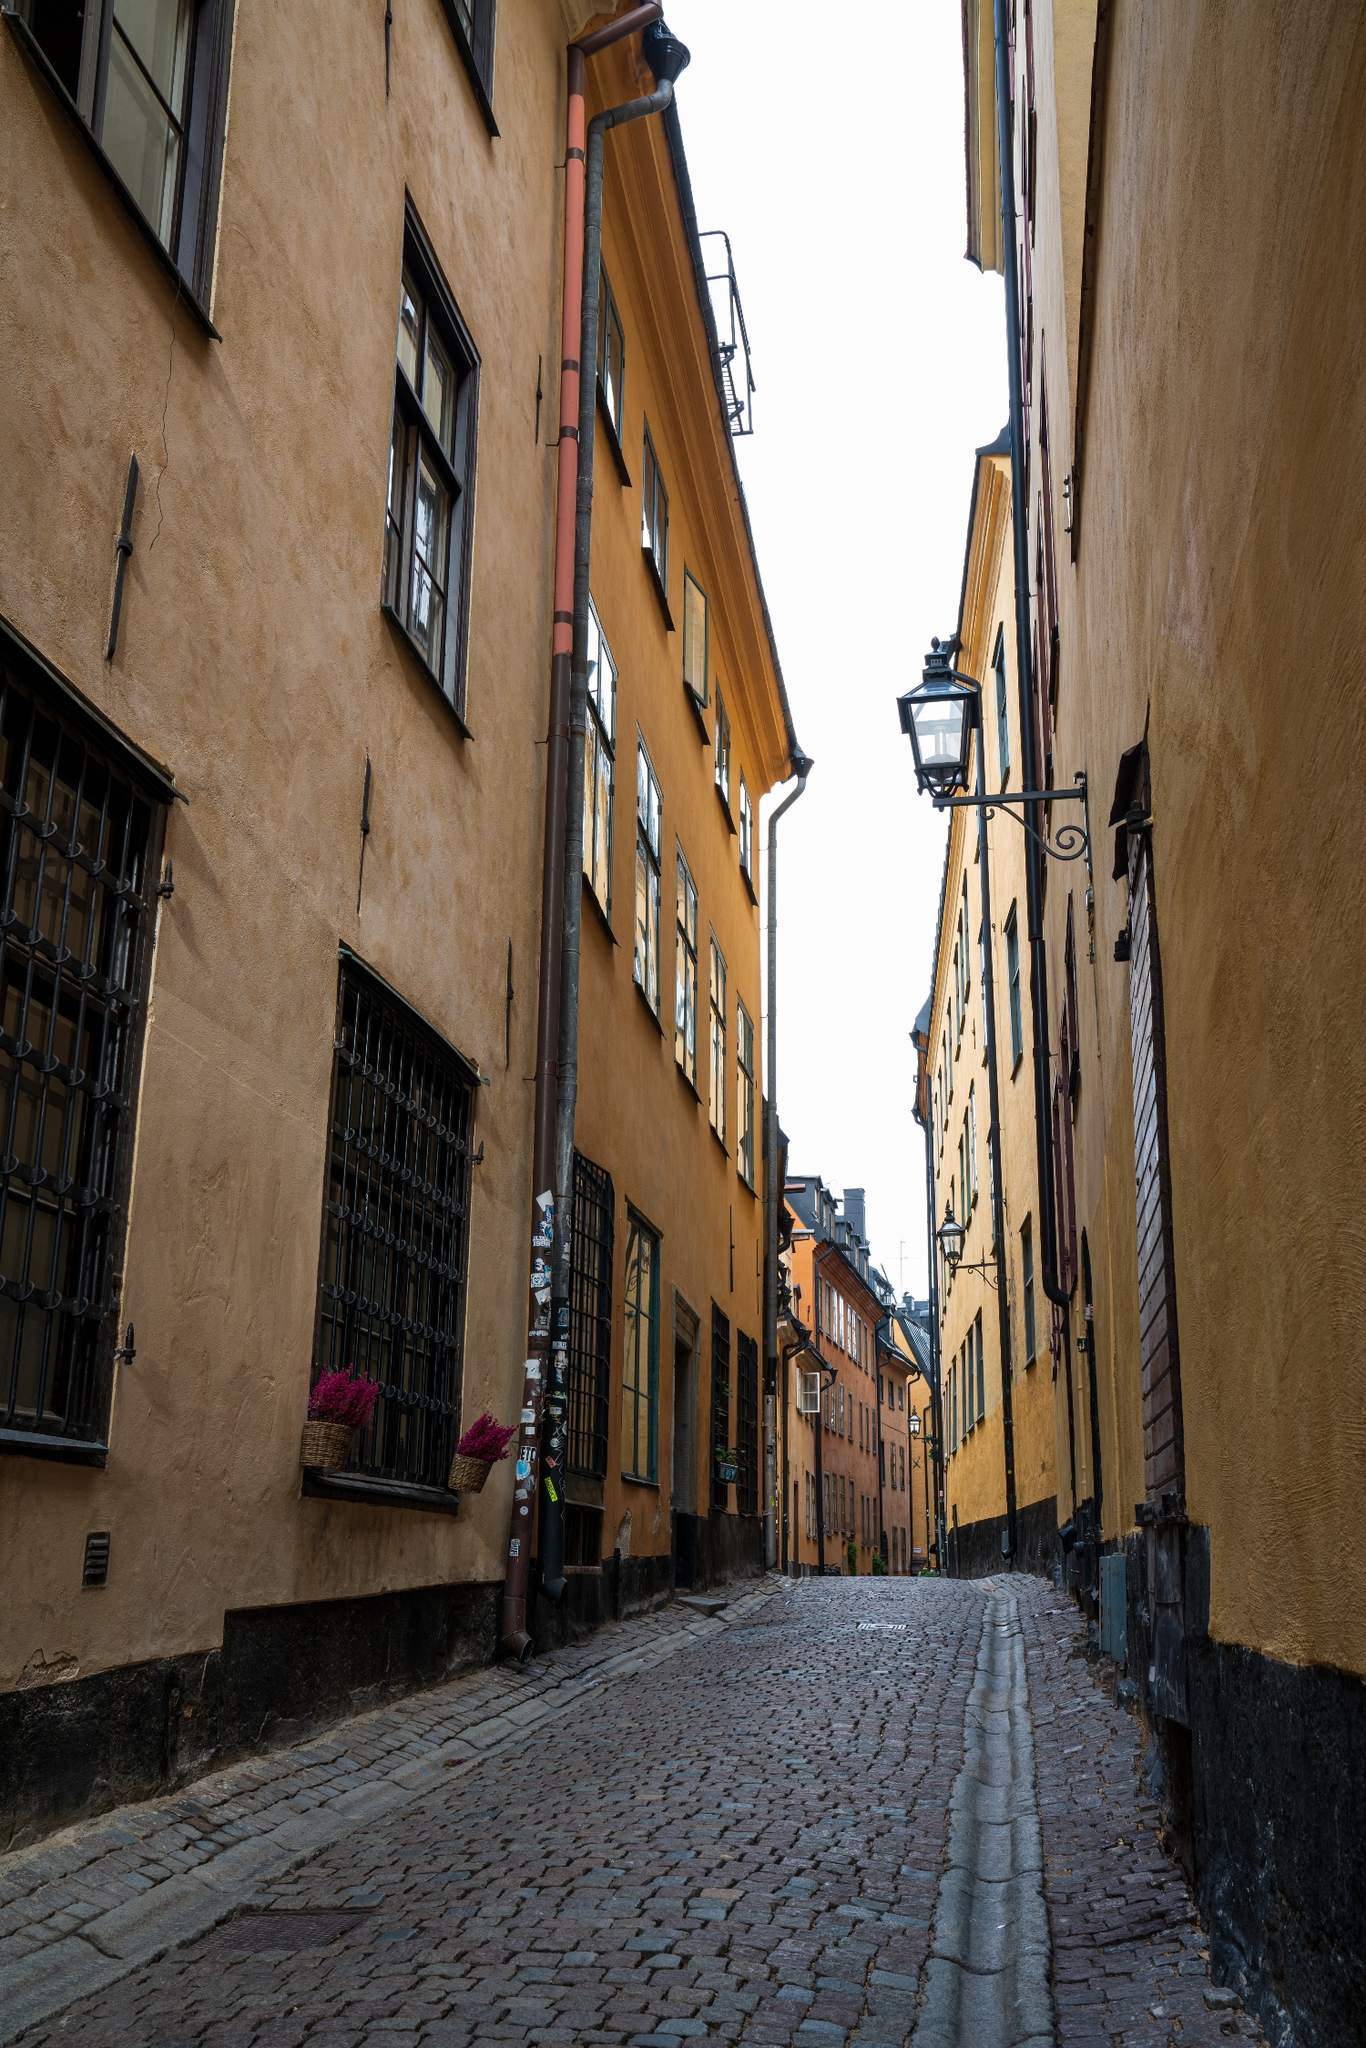Can you elaborate on the elements of the picture provided? The image depicts a picturesque cobblestone street in what appears to be a historic district, possibly in Stockholm, Sweden, judging by the architecture style. The buildings lining the street are tall, with facades in warm shades of yellow and orange, suggesting a well-preserved area possibly dating back several centuries. Features such as wooden shutters and vibrant flower boxes add a residential charm, indicating that these structures might be homes or businesses. The ground perspective of the photograph emphasizes the street's narrowness and the closed distance between the buildings, providing a cozy, intimate feel. Overhead, the overcast sky softens the scene's colors, casting a calm, diffuse light that enhances the timelessness and serenity of the area. 